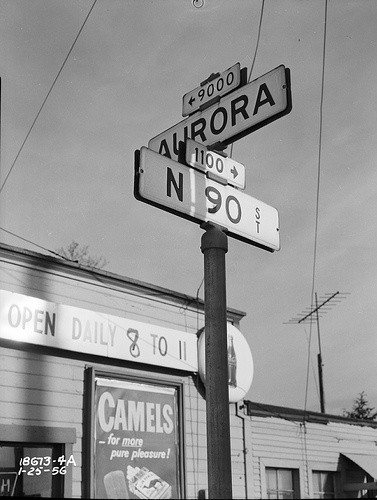Describe the objects in this image and their specific colors. I can see various objects in this image with different colors. 